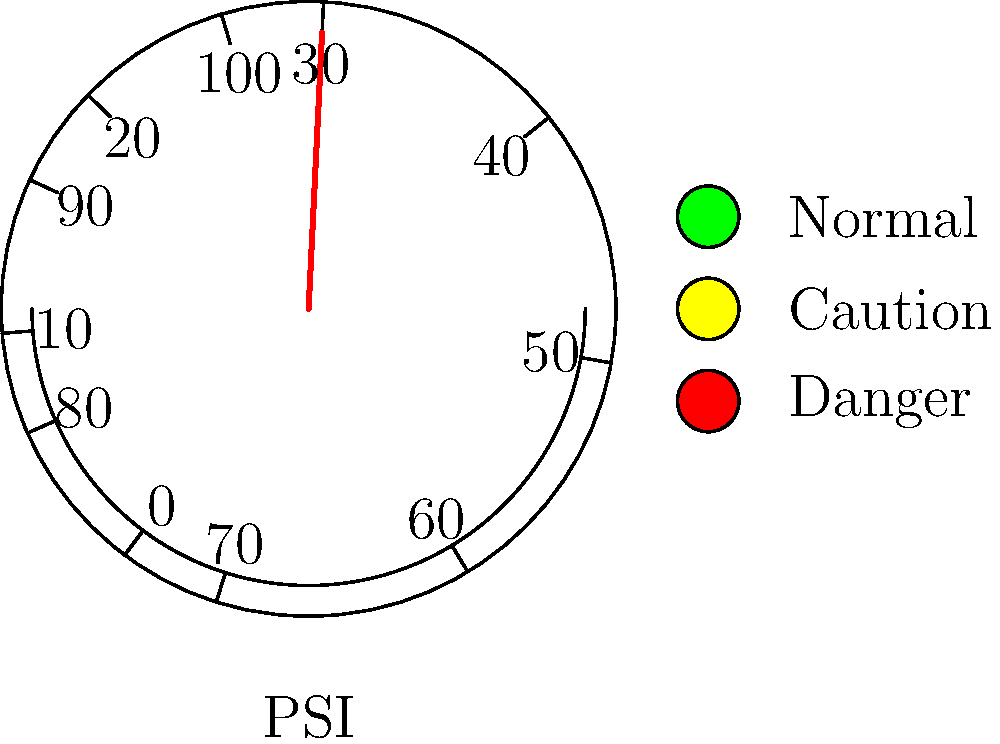Based on the pressure gauge reading and the corresponding visual indicators, what action should be taken regarding the chemical plant's equipment?

A) Continue normal operation
B) Monitor closely and prepare for potential issues
C) Implement immediate corrective measures
D) Shut down the equipment immediately To determine the appropriate action, we need to analyze the pressure gauge reading and the visual indicators:

1. Pressure gauge reading:
   The needle points to approximately 54 PSI on the gauge.

2. Visual indicators:
   - Green light: Normal operation (off)
   - Yellow light: Caution (on)
   - Red light: Danger (off)

3. Interpreting the information:
   - The pressure is slightly above the midpoint of the gauge (50 PSI).
   - The yellow caution light is illuminated, indicating a potential issue.
   - The green (normal) and red (danger) lights are off.

4. Conclusion:
   The combination of a pressure reading above the midpoint and an illuminated caution light suggests that the system is operating outside its optimal range but not yet in a critical state.

5. Recommended action:
   Given the information, the most appropriate action is to monitor the situation closely and prepare for potential issues. This corresponds to option B.

Option A (continue normal operation) is too passive given the caution light.
Option C (implement immediate corrective measures) may be premature without further investigation.
Option D (shut down equipment immediately) is too extreme for the current situation.
Answer: B) Monitor closely and prepare for potential issues 